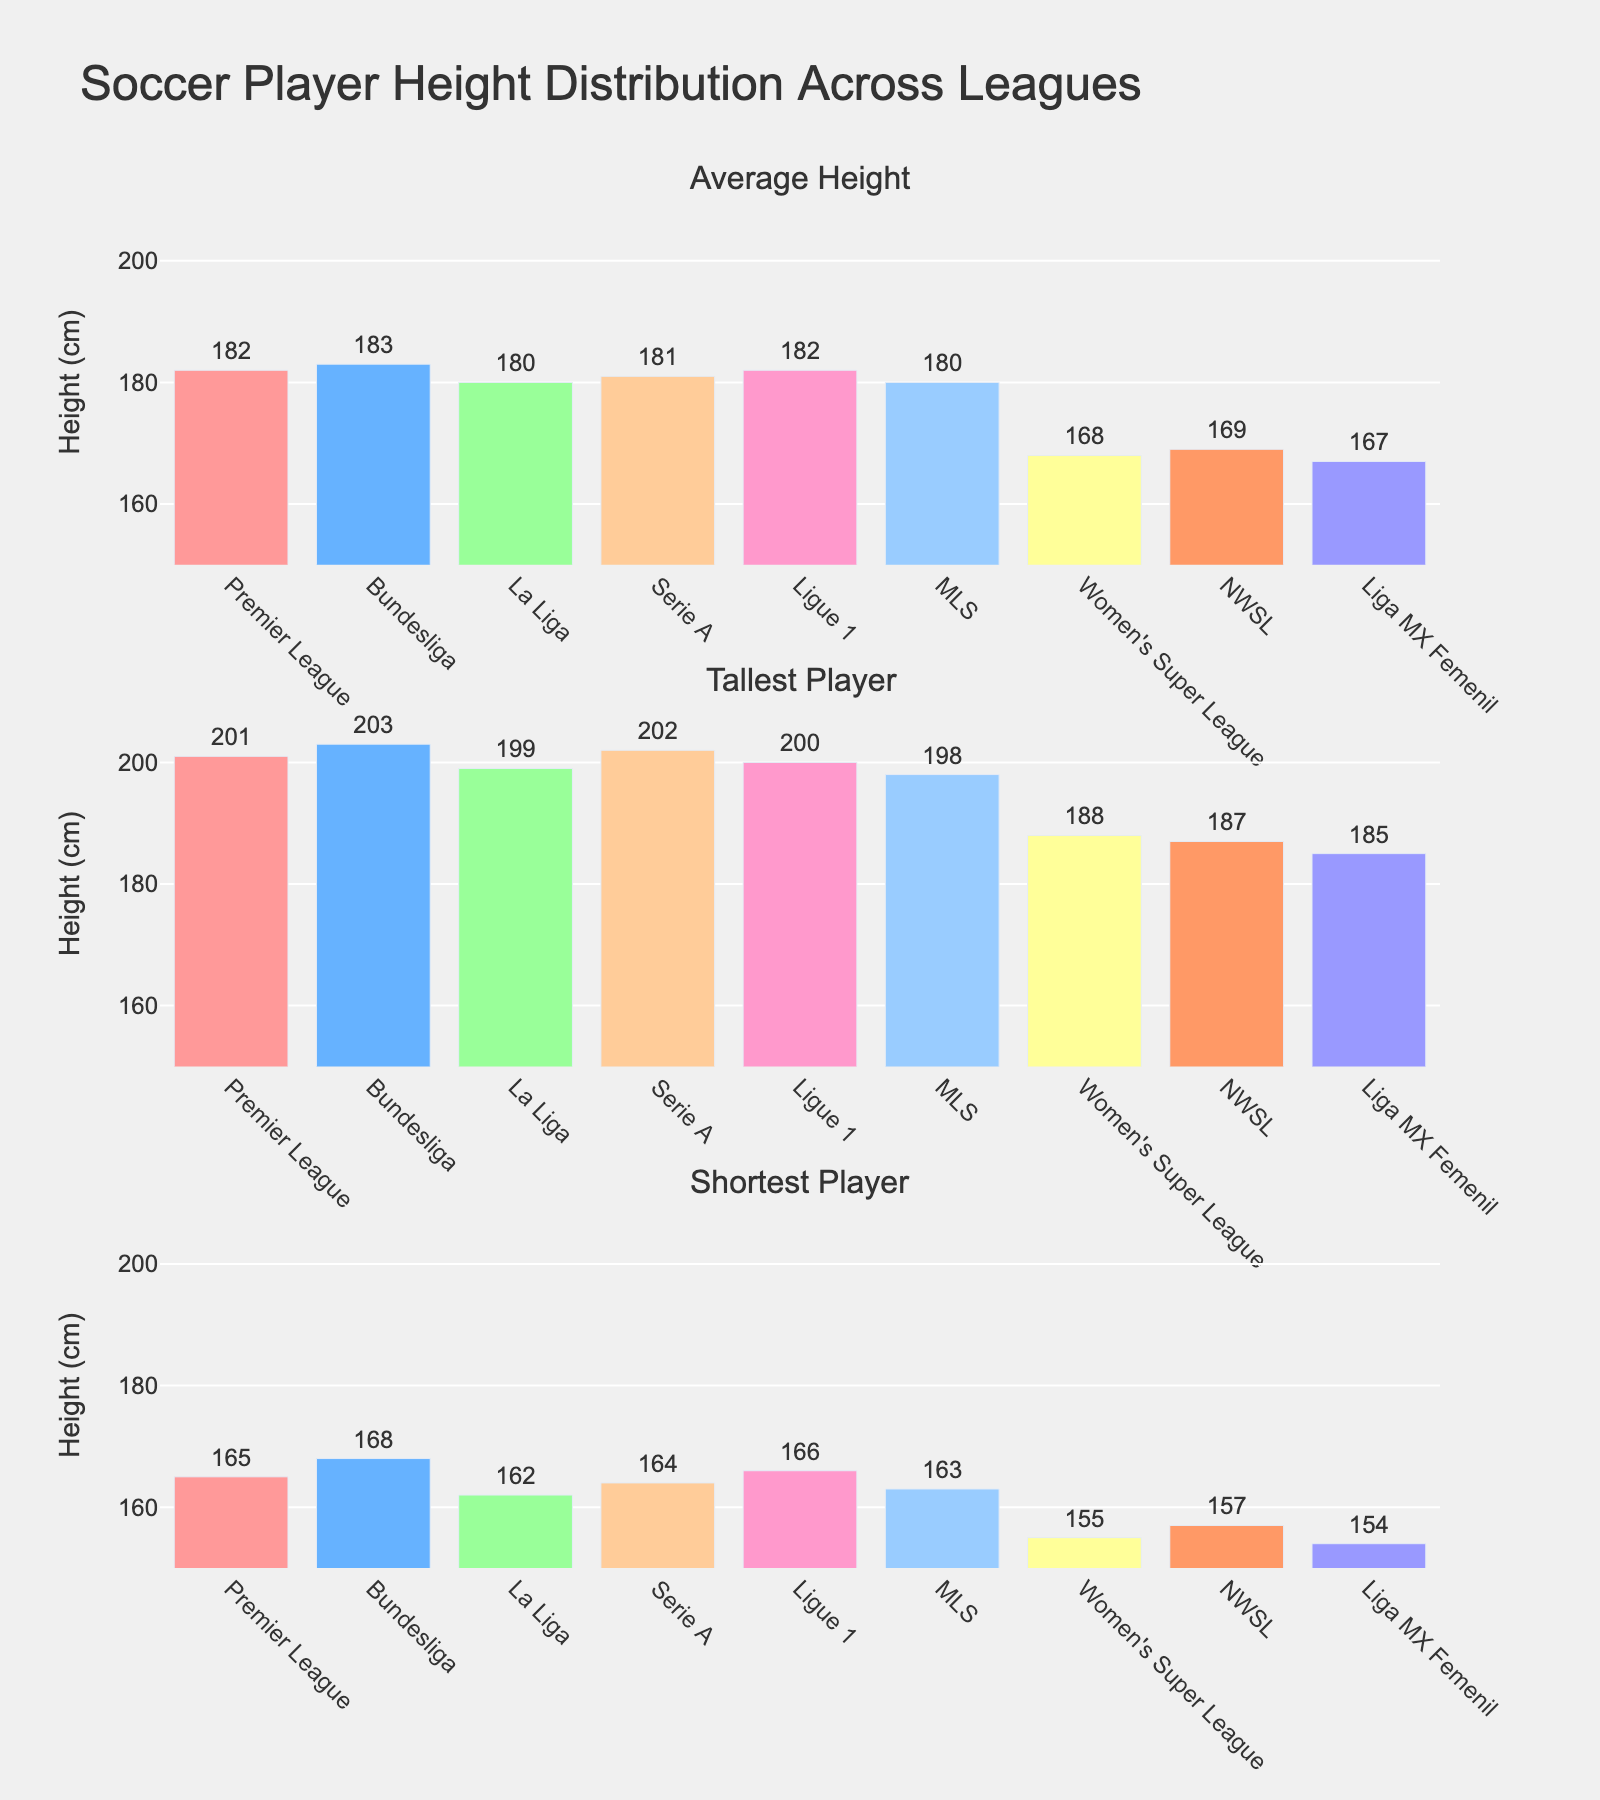What is the average height of players in the Premier League? Locate the bar labeled "Premier League" in the subplot for "Average Height". The text value outside the bar indicates the average height.
Answer: 182 cm Which league has the shortest player overall? Locate the subplot labeled "Shortest Player" and look for the shortest bar. The label below it indicates the league, and the height value is shown just outside the bar.
Answer: Liga MX Femenil How much taller is the average player in the Bundesliga compared to La Liga? Locate the bars labeled "Bundesliga" and "La Liga" in the "Average Height" subplot. Subtract the height of the La Liga bar from the height of the Bundesliga bar.
Answer: 3 cm Which league features the tallest player in the dataset? Locate the subplot for "Tallest Player" and find the tallest bar. The league label just below the bar indicates which league it is.
Answer: Bundesliga Between the NWSL and the Women's Super League, which has the taller average height, and by how much? Find the bars for "NWSL" and "Women's Super League" in the "Average Height" subplot. Compare their heights and subtract the shorter one from the taller one to find the difference.
Answer: NWSL by 1 cm In which subplot do the MLS and Serie A have the same height values? Compare each pair of bars labeled "MLS" and "Serie A" across all three subplots. The subplot where both bars have the same height is the answer.
Answer: None What is the height range of players participating in Ligue 1? Locate the bars labeled "Ligue 1" in the "Tallest Player" and "Shortest Player" subplots. Subtract the value of the shortest player from the value of the tallest player.
Answer: 34 cm Among all leagues, who has the highest average height and how tall are they on average? Locate the tallest bar in the "Average Height" subplot and read the league label and height value.
Answer: Bundesliga with 183 cm How much shorter are the players in the Women's Super League compared to Ligue 1 on average? Find the bars for "Women's Super League" and "Ligue 1" in the "Average Height" subplot. Subtract the height of the Women's Super League bar from the height of the Ligue 1 bar.
Answer: 14 cm 